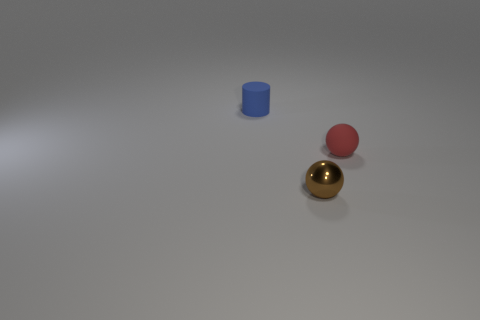Add 2 small brown things. How many objects exist? 5 Subtract 2 balls. How many balls are left? 0 Subtract all brown balls. How many balls are left? 1 Subtract all spheres. How many objects are left? 1 Subtract all green cubes. How many brown spheres are left? 1 Subtract all tiny red rubber objects. Subtract all small red shiny blocks. How many objects are left? 2 Add 1 tiny cylinders. How many tiny cylinders are left? 2 Add 2 small red things. How many small red things exist? 3 Subtract 0 red cylinders. How many objects are left? 3 Subtract all brown cylinders. Subtract all gray blocks. How many cylinders are left? 1 